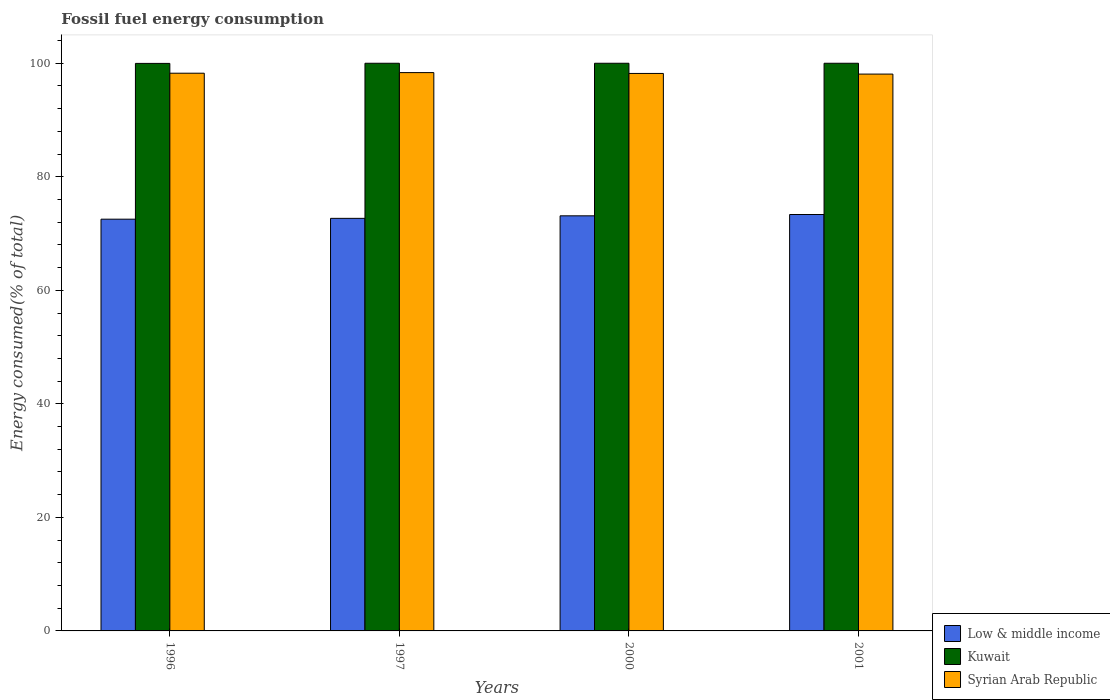How many different coloured bars are there?
Your response must be concise. 3. How many groups of bars are there?
Ensure brevity in your answer.  4. Are the number of bars per tick equal to the number of legend labels?
Make the answer very short. Yes. In how many cases, is the number of bars for a given year not equal to the number of legend labels?
Offer a very short reply. 0. What is the percentage of energy consumed in Low & middle income in 2000?
Provide a short and direct response. 73.12. Across all years, what is the maximum percentage of energy consumed in Syrian Arab Republic?
Your answer should be compact. 98.35. Across all years, what is the minimum percentage of energy consumed in Low & middle income?
Your answer should be compact. 72.53. In which year was the percentage of energy consumed in Kuwait maximum?
Ensure brevity in your answer.  2000. What is the total percentage of energy consumed in Kuwait in the graph?
Provide a short and direct response. 399.97. What is the difference between the percentage of energy consumed in Syrian Arab Republic in 1996 and that in 1997?
Your answer should be very brief. -0.11. What is the difference between the percentage of energy consumed in Kuwait in 2000 and the percentage of energy consumed in Low & middle income in 1997?
Your answer should be very brief. 27.32. What is the average percentage of energy consumed in Low & middle income per year?
Offer a very short reply. 72.92. In the year 1997, what is the difference between the percentage of energy consumed in Kuwait and percentage of energy consumed in Syrian Arab Republic?
Your response must be concise. 1.65. In how many years, is the percentage of energy consumed in Syrian Arab Republic greater than 56 %?
Your answer should be very brief. 4. What is the ratio of the percentage of energy consumed in Syrian Arab Republic in 2000 to that in 2001?
Make the answer very short. 1. What is the difference between the highest and the second highest percentage of energy consumed in Low & middle income?
Your answer should be compact. 0.23. What is the difference between the highest and the lowest percentage of energy consumed in Syrian Arab Republic?
Keep it short and to the point. 0.26. In how many years, is the percentage of energy consumed in Syrian Arab Republic greater than the average percentage of energy consumed in Syrian Arab Republic taken over all years?
Provide a short and direct response. 2. What does the 3rd bar from the left in 2000 represents?
Make the answer very short. Syrian Arab Republic. What does the 3rd bar from the right in 1996 represents?
Keep it short and to the point. Low & middle income. Is it the case that in every year, the sum of the percentage of energy consumed in Syrian Arab Republic and percentage of energy consumed in Low & middle income is greater than the percentage of energy consumed in Kuwait?
Provide a short and direct response. Yes. How many bars are there?
Ensure brevity in your answer.  12. Are the values on the major ticks of Y-axis written in scientific E-notation?
Offer a very short reply. No. Does the graph contain any zero values?
Provide a short and direct response. No. Does the graph contain grids?
Offer a very short reply. No. Where does the legend appear in the graph?
Provide a succinct answer. Bottom right. How many legend labels are there?
Keep it short and to the point. 3. What is the title of the graph?
Keep it short and to the point. Fossil fuel energy consumption. Does "China" appear as one of the legend labels in the graph?
Your response must be concise. No. What is the label or title of the X-axis?
Provide a short and direct response. Years. What is the label or title of the Y-axis?
Your answer should be very brief. Energy consumed(% of total). What is the Energy consumed(% of total) of Low & middle income in 1996?
Provide a succinct answer. 72.53. What is the Energy consumed(% of total) of Kuwait in 1996?
Make the answer very short. 99.97. What is the Energy consumed(% of total) of Syrian Arab Republic in 1996?
Offer a very short reply. 98.25. What is the Energy consumed(% of total) of Low & middle income in 1997?
Make the answer very short. 72.68. What is the Energy consumed(% of total) in Kuwait in 1997?
Provide a short and direct response. 100. What is the Energy consumed(% of total) in Syrian Arab Republic in 1997?
Make the answer very short. 98.35. What is the Energy consumed(% of total) of Low & middle income in 2000?
Provide a short and direct response. 73.12. What is the Energy consumed(% of total) in Kuwait in 2000?
Your answer should be compact. 100. What is the Energy consumed(% of total) of Syrian Arab Republic in 2000?
Your answer should be compact. 98.21. What is the Energy consumed(% of total) in Low & middle income in 2001?
Offer a very short reply. 73.36. What is the Energy consumed(% of total) in Syrian Arab Republic in 2001?
Ensure brevity in your answer.  98.09. Across all years, what is the maximum Energy consumed(% of total) of Low & middle income?
Provide a succinct answer. 73.36. Across all years, what is the maximum Energy consumed(% of total) of Syrian Arab Republic?
Provide a succinct answer. 98.35. Across all years, what is the minimum Energy consumed(% of total) in Low & middle income?
Offer a terse response. 72.53. Across all years, what is the minimum Energy consumed(% of total) in Kuwait?
Your response must be concise. 99.97. Across all years, what is the minimum Energy consumed(% of total) of Syrian Arab Republic?
Give a very brief answer. 98.09. What is the total Energy consumed(% of total) in Low & middle income in the graph?
Provide a succinct answer. 291.69. What is the total Energy consumed(% of total) in Kuwait in the graph?
Ensure brevity in your answer.  399.97. What is the total Energy consumed(% of total) of Syrian Arab Republic in the graph?
Give a very brief answer. 392.9. What is the difference between the Energy consumed(% of total) in Low & middle income in 1996 and that in 1997?
Keep it short and to the point. -0.15. What is the difference between the Energy consumed(% of total) of Kuwait in 1996 and that in 1997?
Offer a terse response. -0.03. What is the difference between the Energy consumed(% of total) of Syrian Arab Republic in 1996 and that in 1997?
Give a very brief answer. -0.11. What is the difference between the Energy consumed(% of total) in Low & middle income in 1996 and that in 2000?
Keep it short and to the point. -0.59. What is the difference between the Energy consumed(% of total) in Kuwait in 1996 and that in 2000?
Your answer should be compact. -0.03. What is the difference between the Energy consumed(% of total) of Syrian Arab Republic in 1996 and that in 2000?
Offer a very short reply. 0.04. What is the difference between the Energy consumed(% of total) of Low & middle income in 1996 and that in 2001?
Offer a very short reply. -0.82. What is the difference between the Energy consumed(% of total) of Kuwait in 1996 and that in 2001?
Give a very brief answer. -0.03. What is the difference between the Energy consumed(% of total) of Syrian Arab Republic in 1996 and that in 2001?
Offer a very short reply. 0.15. What is the difference between the Energy consumed(% of total) of Low & middle income in 1997 and that in 2000?
Your answer should be very brief. -0.45. What is the difference between the Energy consumed(% of total) of Syrian Arab Republic in 1997 and that in 2000?
Keep it short and to the point. 0.15. What is the difference between the Energy consumed(% of total) of Low & middle income in 1997 and that in 2001?
Your answer should be very brief. -0.68. What is the difference between the Energy consumed(% of total) of Syrian Arab Republic in 1997 and that in 2001?
Make the answer very short. 0.26. What is the difference between the Energy consumed(% of total) of Low & middle income in 2000 and that in 2001?
Offer a terse response. -0.23. What is the difference between the Energy consumed(% of total) of Syrian Arab Republic in 2000 and that in 2001?
Your response must be concise. 0.11. What is the difference between the Energy consumed(% of total) in Low & middle income in 1996 and the Energy consumed(% of total) in Kuwait in 1997?
Give a very brief answer. -27.47. What is the difference between the Energy consumed(% of total) in Low & middle income in 1996 and the Energy consumed(% of total) in Syrian Arab Republic in 1997?
Keep it short and to the point. -25.82. What is the difference between the Energy consumed(% of total) of Kuwait in 1996 and the Energy consumed(% of total) of Syrian Arab Republic in 1997?
Offer a terse response. 1.62. What is the difference between the Energy consumed(% of total) in Low & middle income in 1996 and the Energy consumed(% of total) in Kuwait in 2000?
Offer a terse response. -27.47. What is the difference between the Energy consumed(% of total) in Low & middle income in 1996 and the Energy consumed(% of total) in Syrian Arab Republic in 2000?
Offer a very short reply. -25.67. What is the difference between the Energy consumed(% of total) in Kuwait in 1996 and the Energy consumed(% of total) in Syrian Arab Republic in 2000?
Your answer should be very brief. 1.77. What is the difference between the Energy consumed(% of total) in Low & middle income in 1996 and the Energy consumed(% of total) in Kuwait in 2001?
Your answer should be very brief. -27.47. What is the difference between the Energy consumed(% of total) in Low & middle income in 1996 and the Energy consumed(% of total) in Syrian Arab Republic in 2001?
Offer a terse response. -25.56. What is the difference between the Energy consumed(% of total) of Kuwait in 1996 and the Energy consumed(% of total) of Syrian Arab Republic in 2001?
Offer a very short reply. 1.88. What is the difference between the Energy consumed(% of total) of Low & middle income in 1997 and the Energy consumed(% of total) of Kuwait in 2000?
Give a very brief answer. -27.32. What is the difference between the Energy consumed(% of total) of Low & middle income in 1997 and the Energy consumed(% of total) of Syrian Arab Republic in 2000?
Make the answer very short. -25.53. What is the difference between the Energy consumed(% of total) in Kuwait in 1997 and the Energy consumed(% of total) in Syrian Arab Republic in 2000?
Offer a terse response. 1.79. What is the difference between the Energy consumed(% of total) in Low & middle income in 1997 and the Energy consumed(% of total) in Kuwait in 2001?
Your answer should be very brief. -27.32. What is the difference between the Energy consumed(% of total) in Low & middle income in 1997 and the Energy consumed(% of total) in Syrian Arab Republic in 2001?
Make the answer very short. -25.41. What is the difference between the Energy consumed(% of total) of Kuwait in 1997 and the Energy consumed(% of total) of Syrian Arab Republic in 2001?
Make the answer very short. 1.91. What is the difference between the Energy consumed(% of total) of Low & middle income in 2000 and the Energy consumed(% of total) of Kuwait in 2001?
Provide a short and direct response. -26.88. What is the difference between the Energy consumed(% of total) in Low & middle income in 2000 and the Energy consumed(% of total) in Syrian Arab Republic in 2001?
Your answer should be compact. -24.97. What is the difference between the Energy consumed(% of total) of Kuwait in 2000 and the Energy consumed(% of total) of Syrian Arab Republic in 2001?
Your answer should be compact. 1.91. What is the average Energy consumed(% of total) in Low & middle income per year?
Provide a short and direct response. 72.92. What is the average Energy consumed(% of total) in Kuwait per year?
Provide a succinct answer. 99.99. What is the average Energy consumed(% of total) of Syrian Arab Republic per year?
Offer a terse response. 98.22. In the year 1996, what is the difference between the Energy consumed(% of total) in Low & middle income and Energy consumed(% of total) in Kuwait?
Your answer should be very brief. -27.44. In the year 1996, what is the difference between the Energy consumed(% of total) in Low & middle income and Energy consumed(% of total) in Syrian Arab Republic?
Your answer should be very brief. -25.71. In the year 1996, what is the difference between the Energy consumed(% of total) of Kuwait and Energy consumed(% of total) of Syrian Arab Republic?
Keep it short and to the point. 1.73. In the year 1997, what is the difference between the Energy consumed(% of total) in Low & middle income and Energy consumed(% of total) in Kuwait?
Your response must be concise. -27.32. In the year 1997, what is the difference between the Energy consumed(% of total) of Low & middle income and Energy consumed(% of total) of Syrian Arab Republic?
Ensure brevity in your answer.  -25.68. In the year 1997, what is the difference between the Energy consumed(% of total) in Kuwait and Energy consumed(% of total) in Syrian Arab Republic?
Give a very brief answer. 1.65. In the year 2000, what is the difference between the Energy consumed(% of total) of Low & middle income and Energy consumed(% of total) of Kuwait?
Your answer should be compact. -26.88. In the year 2000, what is the difference between the Energy consumed(% of total) of Low & middle income and Energy consumed(% of total) of Syrian Arab Republic?
Offer a terse response. -25.08. In the year 2000, what is the difference between the Energy consumed(% of total) in Kuwait and Energy consumed(% of total) in Syrian Arab Republic?
Your response must be concise. 1.79. In the year 2001, what is the difference between the Energy consumed(% of total) in Low & middle income and Energy consumed(% of total) in Kuwait?
Provide a succinct answer. -26.64. In the year 2001, what is the difference between the Energy consumed(% of total) of Low & middle income and Energy consumed(% of total) of Syrian Arab Republic?
Your answer should be compact. -24.74. In the year 2001, what is the difference between the Energy consumed(% of total) of Kuwait and Energy consumed(% of total) of Syrian Arab Republic?
Keep it short and to the point. 1.91. What is the ratio of the Energy consumed(% of total) of Syrian Arab Republic in 1996 to that in 1997?
Your response must be concise. 1. What is the ratio of the Energy consumed(% of total) of Low & middle income in 1996 to that in 2000?
Your answer should be compact. 0.99. What is the ratio of the Energy consumed(% of total) of Low & middle income in 1996 to that in 2001?
Offer a very short reply. 0.99. What is the ratio of the Energy consumed(% of total) of Kuwait in 1997 to that in 2001?
Your answer should be very brief. 1. What is the ratio of the Energy consumed(% of total) of Syrian Arab Republic in 1997 to that in 2001?
Provide a short and direct response. 1. What is the difference between the highest and the second highest Energy consumed(% of total) of Low & middle income?
Make the answer very short. 0.23. What is the difference between the highest and the second highest Energy consumed(% of total) in Syrian Arab Republic?
Ensure brevity in your answer.  0.11. What is the difference between the highest and the lowest Energy consumed(% of total) in Low & middle income?
Your response must be concise. 0.82. What is the difference between the highest and the lowest Energy consumed(% of total) of Kuwait?
Provide a succinct answer. 0.03. What is the difference between the highest and the lowest Energy consumed(% of total) in Syrian Arab Republic?
Your answer should be very brief. 0.26. 